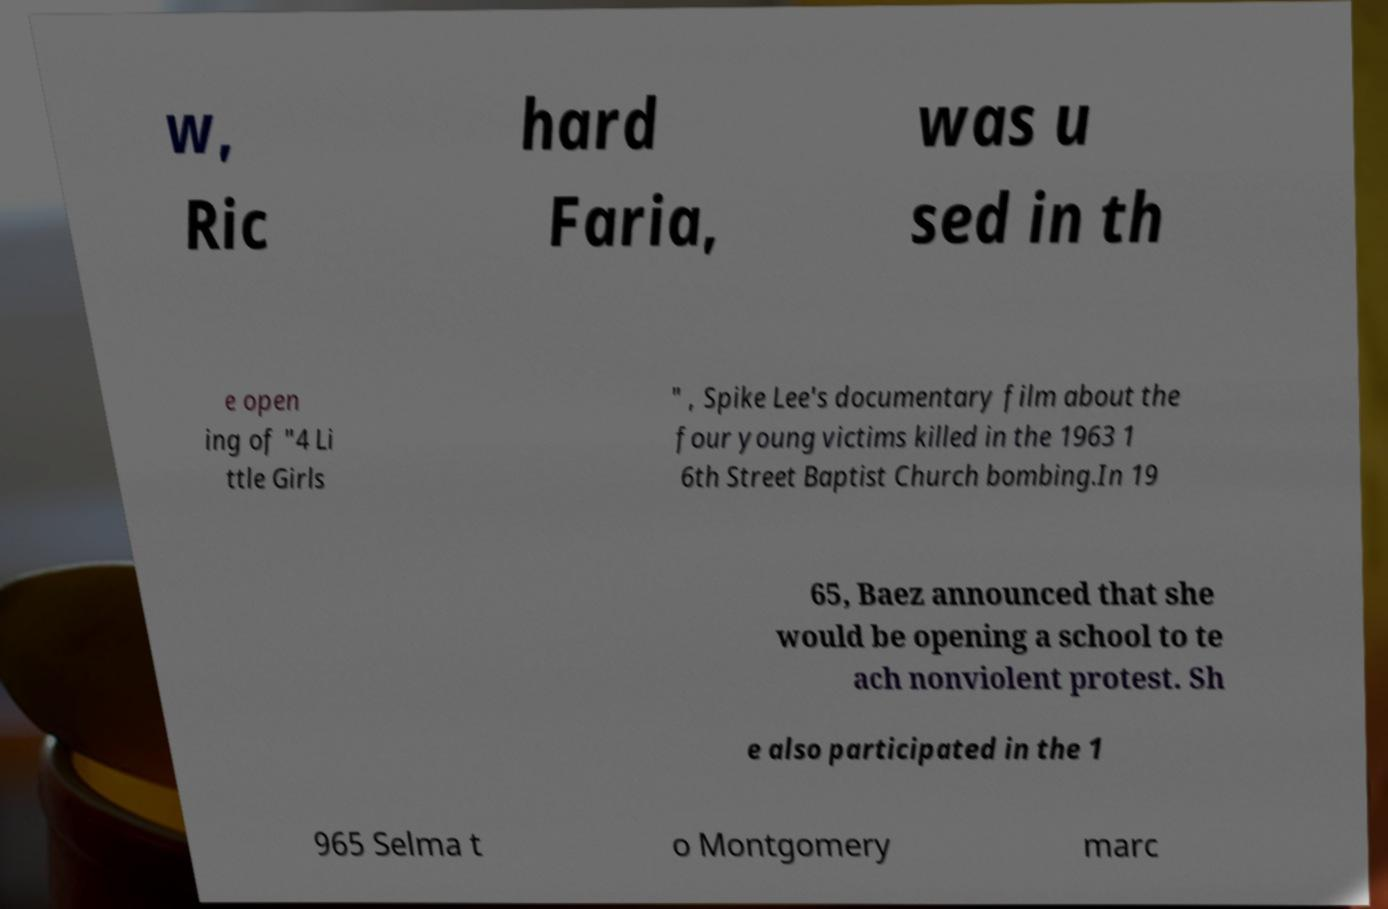Please read and relay the text visible in this image. What does it say? w, Ric hard Faria, was u sed in th e open ing of "4 Li ttle Girls " , Spike Lee's documentary film about the four young victims killed in the 1963 1 6th Street Baptist Church bombing.In 19 65, Baez announced that she would be opening a school to te ach nonviolent protest. Sh e also participated in the 1 965 Selma t o Montgomery marc 